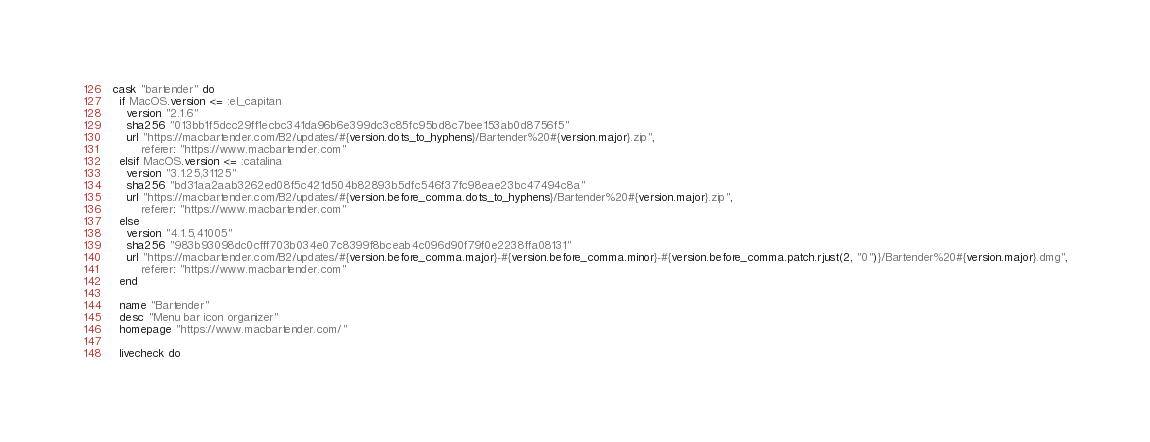Convert code to text. <code><loc_0><loc_0><loc_500><loc_500><_Ruby_>cask "bartender" do
  if MacOS.version <= :el_capitan
    version "2.1.6"
    sha256 "013bb1f5dcc29ff1ecbc341da96b6e399dc3c85fc95bd8c7bee153ab0d8756f5"
    url "https://macbartender.com/B2/updates/#{version.dots_to_hyphens}/Bartender%20#{version.major}.zip",
        referer: "https://www.macbartender.com"
  elsif MacOS.version <= :catalina
    version "3.1.25,31125"
    sha256 "bd31aa2aab3262ed08f5c421d504b82893b5dfc546f37fc98eae23bc47494c8a"
    url "https://macbartender.com/B2/updates/#{version.before_comma.dots_to_hyphens}/Bartender%20#{version.major}.zip",
        referer: "https://www.macbartender.com"
  else
    version "4.1.5,41005"
    sha256 "983b93098dc0cfff703b034e07c8399f8bceab4c096d90f79f0e2238ffa08131"
    url "https://macbartender.com/B2/updates/#{version.before_comma.major}-#{version.before_comma.minor}-#{version.before_comma.patch.rjust(2, "0")}/Bartender%20#{version.major}.dmg",
        referer: "https://www.macbartender.com"
  end

  name "Bartender"
  desc "Menu bar icon organizer"
  homepage "https://www.macbartender.com/"

  livecheck do</code> 